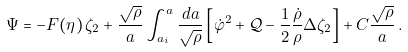<formula> <loc_0><loc_0><loc_500><loc_500>\Psi = - F ( \eta ) \, \zeta _ { 2 } + \frac { \sqrt { \rho } } { a } \int _ { a _ { i } } ^ { a } \frac { d a } { \sqrt { \rho } } \left [ \dot { \varphi } ^ { 2 } + { \mathcal { Q } } - \frac { 1 } { 2 } \frac { \dot { \rho } } { \rho } \Delta \zeta _ { 2 } \right ] + C \frac { \sqrt { \rho } } { a } \, .</formula> 